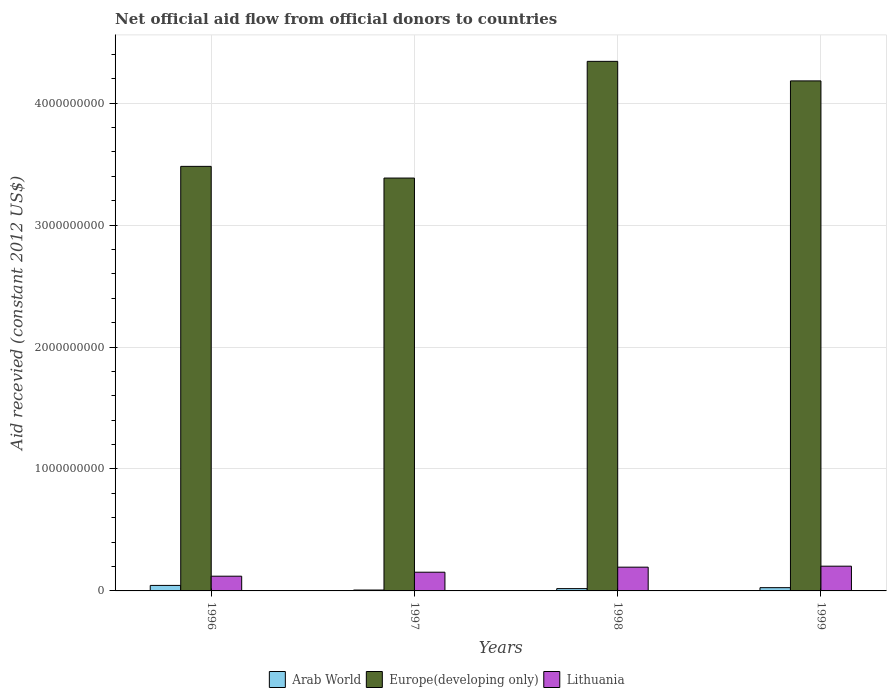How many different coloured bars are there?
Give a very brief answer. 3. How many groups of bars are there?
Offer a very short reply. 4. Are the number of bars per tick equal to the number of legend labels?
Your answer should be compact. Yes. How many bars are there on the 2nd tick from the right?
Offer a terse response. 3. What is the total aid received in Arab World in 1996?
Make the answer very short. 4.51e+07. Across all years, what is the maximum total aid received in Europe(developing only)?
Your answer should be compact. 4.34e+09. Across all years, what is the minimum total aid received in Europe(developing only)?
Offer a terse response. 3.39e+09. In which year was the total aid received in Arab World minimum?
Keep it short and to the point. 1997. What is the total total aid received in Arab World in the graph?
Give a very brief answer. 9.80e+07. What is the difference between the total aid received in Europe(developing only) in 1998 and that in 1999?
Offer a very short reply. 1.60e+08. What is the difference between the total aid received in Europe(developing only) in 1997 and the total aid received in Lithuania in 1998?
Your answer should be very brief. 3.19e+09. What is the average total aid received in Lithuania per year?
Make the answer very short. 1.68e+08. In the year 1997, what is the difference between the total aid received in Lithuania and total aid received in Europe(developing only)?
Ensure brevity in your answer.  -3.23e+09. In how many years, is the total aid received in Arab World greater than 4000000000 US$?
Make the answer very short. 0. What is the ratio of the total aid received in Arab World in 1996 to that in 1998?
Your response must be concise. 2.38. Is the difference between the total aid received in Lithuania in 1996 and 1999 greater than the difference between the total aid received in Europe(developing only) in 1996 and 1999?
Offer a very short reply. Yes. What is the difference between the highest and the second highest total aid received in Europe(developing only)?
Keep it short and to the point. 1.60e+08. What is the difference between the highest and the lowest total aid received in Arab World?
Ensure brevity in your answer.  3.78e+07. Is the sum of the total aid received in Arab World in 1996 and 1998 greater than the maximum total aid received in Europe(developing only) across all years?
Your answer should be very brief. No. What does the 1st bar from the left in 1997 represents?
Make the answer very short. Arab World. What does the 2nd bar from the right in 1997 represents?
Your answer should be compact. Europe(developing only). Is it the case that in every year, the sum of the total aid received in Europe(developing only) and total aid received in Arab World is greater than the total aid received in Lithuania?
Provide a succinct answer. Yes. Are the values on the major ticks of Y-axis written in scientific E-notation?
Offer a terse response. No. Does the graph contain any zero values?
Make the answer very short. No. Does the graph contain grids?
Ensure brevity in your answer.  Yes. Where does the legend appear in the graph?
Give a very brief answer. Bottom center. How many legend labels are there?
Ensure brevity in your answer.  3. What is the title of the graph?
Give a very brief answer. Net official aid flow from official donors to countries. What is the label or title of the Y-axis?
Ensure brevity in your answer.  Aid recevied (constant 2012 US$). What is the Aid recevied (constant 2012 US$) of Arab World in 1996?
Your answer should be very brief. 4.51e+07. What is the Aid recevied (constant 2012 US$) in Europe(developing only) in 1996?
Your response must be concise. 3.48e+09. What is the Aid recevied (constant 2012 US$) of Lithuania in 1996?
Provide a succinct answer. 1.21e+08. What is the Aid recevied (constant 2012 US$) in Arab World in 1997?
Ensure brevity in your answer.  7.29e+06. What is the Aid recevied (constant 2012 US$) of Europe(developing only) in 1997?
Offer a terse response. 3.39e+09. What is the Aid recevied (constant 2012 US$) in Lithuania in 1997?
Offer a very short reply. 1.53e+08. What is the Aid recevied (constant 2012 US$) in Arab World in 1998?
Keep it short and to the point. 1.90e+07. What is the Aid recevied (constant 2012 US$) of Europe(developing only) in 1998?
Provide a succinct answer. 4.34e+09. What is the Aid recevied (constant 2012 US$) in Lithuania in 1998?
Your answer should be compact. 1.95e+08. What is the Aid recevied (constant 2012 US$) in Arab World in 1999?
Your response must be concise. 2.67e+07. What is the Aid recevied (constant 2012 US$) of Europe(developing only) in 1999?
Offer a very short reply. 4.18e+09. What is the Aid recevied (constant 2012 US$) in Lithuania in 1999?
Your response must be concise. 2.03e+08. Across all years, what is the maximum Aid recevied (constant 2012 US$) in Arab World?
Your answer should be compact. 4.51e+07. Across all years, what is the maximum Aid recevied (constant 2012 US$) of Europe(developing only)?
Your answer should be compact. 4.34e+09. Across all years, what is the maximum Aid recevied (constant 2012 US$) in Lithuania?
Your answer should be very brief. 2.03e+08. Across all years, what is the minimum Aid recevied (constant 2012 US$) in Arab World?
Ensure brevity in your answer.  7.29e+06. Across all years, what is the minimum Aid recevied (constant 2012 US$) in Europe(developing only)?
Your answer should be compact. 3.39e+09. Across all years, what is the minimum Aid recevied (constant 2012 US$) in Lithuania?
Your response must be concise. 1.21e+08. What is the total Aid recevied (constant 2012 US$) of Arab World in the graph?
Your answer should be very brief. 9.80e+07. What is the total Aid recevied (constant 2012 US$) in Europe(developing only) in the graph?
Make the answer very short. 1.54e+1. What is the total Aid recevied (constant 2012 US$) of Lithuania in the graph?
Ensure brevity in your answer.  6.72e+08. What is the difference between the Aid recevied (constant 2012 US$) in Arab World in 1996 and that in 1997?
Your answer should be compact. 3.78e+07. What is the difference between the Aid recevied (constant 2012 US$) of Europe(developing only) in 1996 and that in 1997?
Give a very brief answer. 9.58e+07. What is the difference between the Aid recevied (constant 2012 US$) in Lithuania in 1996 and that in 1997?
Offer a very short reply. -3.27e+07. What is the difference between the Aid recevied (constant 2012 US$) of Arab World in 1996 and that in 1998?
Ensure brevity in your answer.  2.62e+07. What is the difference between the Aid recevied (constant 2012 US$) in Europe(developing only) in 1996 and that in 1998?
Provide a succinct answer. -8.61e+08. What is the difference between the Aid recevied (constant 2012 US$) in Lithuania in 1996 and that in 1998?
Your answer should be very brief. -7.41e+07. What is the difference between the Aid recevied (constant 2012 US$) in Arab World in 1996 and that in 1999?
Your answer should be compact. 1.85e+07. What is the difference between the Aid recevied (constant 2012 US$) of Europe(developing only) in 1996 and that in 1999?
Your answer should be compact. -7.01e+08. What is the difference between the Aid recevied (constant 2012 US$) of Lithuania in 1996 and that in 1999?
Make the answer very short. -8.22e+07. What is the difference between the Aid recevied (constant 2012 US$) of Arab World in 1997 and that in 1998?
Provide a short and direct response. -1.17e+07. What is the difference between the Aid recevied (constant 2012 US$) in Europe(developing only) in 1997 and that in 1998?
Keep it short and to the point. -9.57e+08. What is the difference between the Aid recevied (constant 2012 US$) of Lithuania in 1997 and that in 1998?
Ensure brevity in your answer.  -4.14e+07. What is the difference between the Aid recevied (constant 2012 US$) of Arab World in 1997 and that in 1999?
Your answer should be very brief. -1.94e+07. What is the difference between the Aid recevied (constant 2012 US$) in Europe(developing only) in 1997 and that in 1999?
Provide a short and direct response. -7.97e+08. What is the difference between the Aid recevied (constant 2012 US$) in Lithuania in 1997 and that in 1999?
Offer a very short reply. -4.95e+07. What is the difference between the Aid recevied (constant 2012 US$) in Arab World in 1998 and that in 1999?
Provide a short and direct response. -7.71e+06. What is the difference between the Aid recevied (constant 2012 US$) of Europe(developing only) in 1998 and that in 1999?
Your response must be concise. 1.60e+08. What is the difference between the Aid recevied (constant 2012 US$) of Lithuania in 1998 and that in 1999?
Ensure brevity in your answer.  -8.09e+06. What is the difference between the Aid recevied (constant 2012 US$) of Arab World in 1996 and the Aid recevied (constant 2012 US$) of Europe(developing only) in 1997?
Make the answer very short. -3.34e+09. What is the difference between the Aid recevied (constant 2012 US$) of Arab World in 1996 and the Aid recevied (constant 2012 US$) of Lithuania in 1997?
Offer a terse response. -1.08e+08. What is the difference between the Aid recevied (constant 2012 US$) in Europe(developing only) in 1996 and the Aid recevied (constant 2012 US$) in Lithuania in 1997?
Your answer should be very brief. 3.33e+09. What is the difference between the Aid recevied (constant 2012 US$) in Arab World in 1996 and the Aid recevied (constant 2012 US$) in Europe(developing only) in 1998?
Provide a short and direct response. -4.30e+09. What is the difference between the Aid recevied (constant 2012 US$) of Arab World in 1996 and the Aid recevied (constant 2012 US$) of Lithuania in 1998?
Give a very brief answer. -1.50e+08. What is the difference between the Aid recevied (constant 2012 US$) in Europe(developing only) in 1996 and the Aid recevied (constant 2012 US$) in Lithuania in 1998?
Offer a terse response. 3.29e+09. What is the difference between the Aid recevied (constant 2012 US$) of Arab World in 1996 and the Aid recevied (constant 2012 US$) of Europe(developing only) in 1999?
Your response must be concise. -4.14e+09. What is the difference between the Aid recevied (constant 2012 US$) in Arab World in 1996 and the Aid recevied (constant 2012 US$) in Lithuania in 1999?
Provide a short and direct response. -1.58e+08. What is the difference between the Aid recevied (constant 2012 US$) of Europe(developing only) in 1996 and the Aid recevied (constant 2012 US$) of Lithuania in 1999?
Your answer should be compact. 3.28e+09. What is the difference between the Aid recevied (constant 2012 US$) in Arab World in 1997 and the Aid recevied (constant 2012 US$) in Europe(developing only) in 1998?
Your answer should be compact. -4.34e+09. What is the difference between the Aid recevied (constant 2012 US$) in Arab World in 1997 and the Aid recevied (constant 2012 US$) in Lithuania in 1998?
Provide a short and direct response. -1.88e+08. What is the difference between the Aid recevied (constant 2012 US$) in Europe(developing only) in 1997 and the Aid recevied (constant 2012 US$) in Lithuania in 1998?
Ensure brevity in your answer.  3.19e+09. What is the difference between the Aid recevied (constant 2012 US$) in Arab World in 1997 and the Aid recevied (constant 2012 US$) in Europe(developing only) in 1999?
Your answer should be very brief. -4.18e+09. What is the difference between the Aid recevied (constant 2012 US$) in Arab World in 1997 and the Aid recevied (constant 2012 US$) in Lithuania in 1999?
Keep it short and to the point. -1.96e+08. What is the difference between the Aid recevied (constant 2012 US$) in Europe(developing only) in 1997 and the Aid recevied (constant 2012 US$) in Lithuania in 1999?
Offer a terse response. 3.18e+09. What is the difference between the Aid recevied (constant 2012 US$) in Arab World in 1998 and the Aid recevied (constant 2012 US$) in Europe(developing only) in 1999?
Provide a succinct answer. -4.16e+09. What is the difference between the Aid recevied (constant 2012 US$) of Arab World in 1998 and the Aid recevied (constant 2012 US$) of Lithuania in 1999?
Give a very brief answer. -1.84e+08. What is the difference between the Aid recevied (constant 2012 US$) in Europe(developing only) in 1998 and the Aid recevied (constant 2012 US$) in Lithuania in 1999?
Your answer should be compact. 4.14e+09. What is the average Aid recevied (constant 2012 US$) of Arab World per year?
Ensure brevity in your answer.  2.45e+07. What is the average Aid recevied (constant 2012 US$) of Europe(developing only) per year?
Ensure brevity in your answer.  3.85e+09. What is the average Aid recevied (constant 2012 US$) of Lithuania per year?
Give a very brief answer. 1.68e+08. In the year 1996, what is the difference between the Aid recevied (constant 2012 US$) of Arab World and Aid recevied (constant 2012 US$) of Europe(developing only)?
Provide a succinct answer. -3.44e+09. In the year 1996, what is the difference between the Aid recevied (constant 2012 US$) in Arab World and Aid recevied (constant 2012 US$) in Lithuania?
Give a very brief answer. -7.57e+07. In the year 1996, what is the difference between the Aid recevied (constant 2012 US$) in Europe(developing only) and Aid recevied (constant 2012 US$) in Lithuania?
Make the answer very short. 3.36e+09. In the year 1997, what is the difference between the Aid recevied (constant 2012 US$) of Arab World and Aid recevied (constant 2012 US$) of Europe(developing only)?
Your answer should be very brief. -3.38e+09. In the year 1997, what is the difference between the Aid recevied (constant 2012 US$) of Arab World and Aid recevied (constant 2012 US$) of Lithuania?
Your answer should be very brief. -1.46e+08. In the year 1997, what is the difference between the Aid recevied (constant 2012 US$) of Europe(developing only) and Aid recevied (constant 2012 US$) of Lithuania?
Offer a terse response. 3.23e+09. In the year 1998, what is the difference between the Aid recevied (constant 2012 US$) of Arab World and Aid recevied (constant 2012 US$) of Europe(developing only)?
Offer a terse response. -4.32e+09. In the year 1998, what is the difference between the Aid recevied (constant 2012 US$) in Arab World and Aid recevied (constant 2012 US$) in Lithuania?
Make the answer very short. -1.76e+08. In the year 1998, what is the difference between the Aid recevied (constant 2012 US$) of Europe(developing only) and Aid recevied (constant 2012 US$) of Lithuania?
Give a very brief answer. 4.15e+09. In the year 1999, what is the difference between the Aid recevied (constant 2012 US$) in Arab World and Aid recevied (constant 2012 US$) in Europe(developing only)?
Offer a terse response. -4.16e+09. In the year 1999, what is the difference between the Aid recevied (constant 2012 US$) in Arab World and Aid recevied (constant 2012 US$) in Lithuania?
Your response must be concise. -1.76e+08. In the year 1999, what is the difference between the Aid recevied (constant 2012 US$) in Europe(developing only) and Aid recevied (constant 2012 US$) in Lithuania?
Give a very brief answer. 3.98e+09. What is the ratio of the Aid recevied (constant 2012 US$) in Arab World in 1996 to that in 1997?
Your answer should be very brief. 6.19. What is the ratio of the Aid recevied (constant 2012 US$) of Europe(developing only) in 1996 to that in 1997?
Offer a terse response. 1.03. What is the ratio of the Aid recevied (constant 2012 US$) in Lithuania in 1996 to that in 1997?
Offer a very short reply. 0.79. What is the ratio of the Aid recevied (constant 2012 US$) of Arab World in 1996 to that in 1998?
Make the answer very short. 2.38. What is the ratio of the Aid recevied (constant 2012 US$) of Europe(developing only) in 1996 to that in 1998?
Keep it short and to the point. 0.8. What is the ratio of the Aid recevied (constant 2012 US$) of Lithuania in 1996 to that in 1998?
Make the answer very short. 0.62. What is the ratio of the Aid recevied (constant 2012 US$) in Arab World in 1996 to that in 1999?
Ensure brevity in your answer.  1.69. What is the ratio of the Aid recevied (constant 2012 US$) in Europe(developing only) in 1996 to that in 1999?
Offer a very short reply. 0.83. What is the ratio of the Aid recevied (constant 2012 US$) in Lithuania in 1996 to that in 1999?
Offer a very short reply. 0.6. What is the ratio of the Aid recevied (constant 2012 US$) in Arab World in 1997 to that in 1998?
Offer a very short reply. 0.38. What is the ratio of the Aid recevied (constant 2012 US$) in Europe(developing only) in 1997 to that in 1998?
Provide a succinct answer. 0.78. What is the ratio of the Aid recevied (constant 2012 US$) of Lithuania in 1997 to that in 1998?
Your answer should be very brief. 0.79. What is the ratio of the Aid recevied (constant 2012 US$) of Arab World in 1997 to that in 1999?
Provide a short and direct response. 0.27. What is the ratio of the Aid recevied (constant 2012 US$) of Europe(developing only) in 1997 to that in 1999?
Give a very brief answer. 0.81. What is the ratio of the Aid recevied (constant 2012 US$) of Lithuania in 1997 to that in 1999?
Your answer should be compact. 0.76. What is the ratio of the Aid recevied (constant 2012 US$) in Arab World in 1998 to that in 1999?
Offer a very short reply. 0.71. What is the ratio of the Aid recevied (constant 2012 US$) of Europe(developing only) in 1998 to that in 1999?
Offer a very short reply. 1.04. What is the ratio of the Aid recevied (constant 2012 US$) of Lithuania in 1998 to that in 1999?
Ensure brevity in your answer.  0.96. What is the difference between the highest and the second highest Aid recevied (constant 2012 US$) in Arab World?
Your answer should be very brief. 1.85e+07. What is the difference between the highest and the second highest Aid recevied (constant 2012 US$) of Europe(developing only)?
Offer a very short reply. 1.60e+08. What is the difference between the highest and the second highest Aid recevied (constant 2012 US$) in Lithuania?
Provide a succinct answer. 8.09e+06. What is the difference between the highest and the lowest Aid recevied (constant 2012 US$) of Arab World?
Your response must be concise. 3.78e+07. What is the difference between the highest and the lowest Aid recevied (constant 2012 US$) in Europe(developing only)?
Provide a succinct answer. 9.57e+08. What is the difference between the highest and the lowest Aid recevied (constant 2012 US$) of Lithuania?
Offer a terse response. 8.22e+07. 